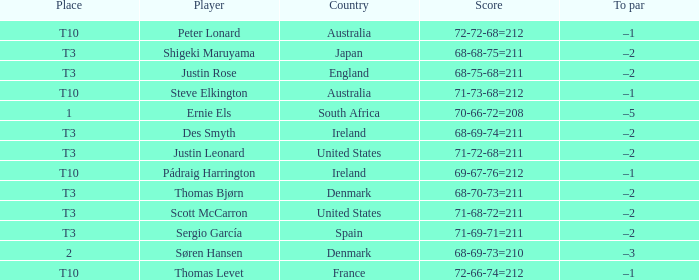What was the place when the score was 71-69-71=211? T3. 